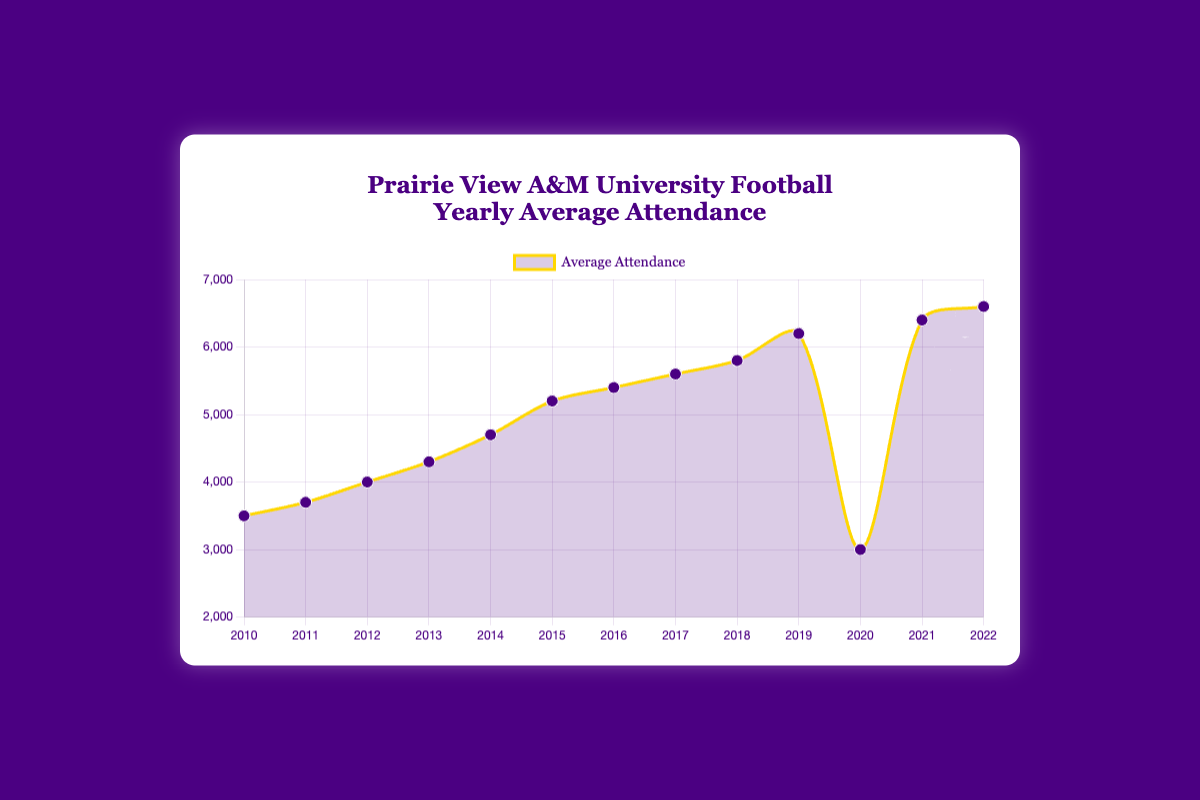What is the yearly average attendance in 2012? Look for the data point corresponding to the year 2012 on the plot and read its average attendance value.
Answer: 4000 Did the yearly average attendance increase or decrease from 2019 to 2020? Compare the average attendance in 2019 with the average attendance in 2020 by looking at the respective data points on the plot.
Answer: Decrease Which year experienced the lowest average attendance? Identify the data point on the plot with the lowest y-value (attendance).
Answer: 2020 How much did the average attendance increase from 2010 to 2014? Find the difference between the average attendance in 2014 and 2010 by subtracting the 2010 value from the 2014 value.
Answer: 1200 What is the highest average attendance recorded and in which year? Locate the data point with the highest y-value on the plot and note its corresponding year.
Answer: 6600 in 2022 Between which two consecutive years did the average attendance increase the most? Compare the difference in average attendance between consecutive years and identify the pair with the largest difference.
Answer: 2020 and 2021 By how much did the average attendance change from 2010 to 2022? Subtract the average attendance in 2010 from the average attendance in 2022.
Answer: 3100 Which years had an average attendance greater than 6000? Identify the years where the data points are above the 6000 y-value on the plot.
Answer: 2019, 2021, 2022 What's the average of the yearly average attendances from 2010 to 2015? Sum the average attendances from 2010 to 2015 and divide by 6 (the number of years). Sum = (3500 + 3700 + 4000 + 4300 + 4700 + 5200); 25400 / 6 = 4233.33
Answer: 4233.33 